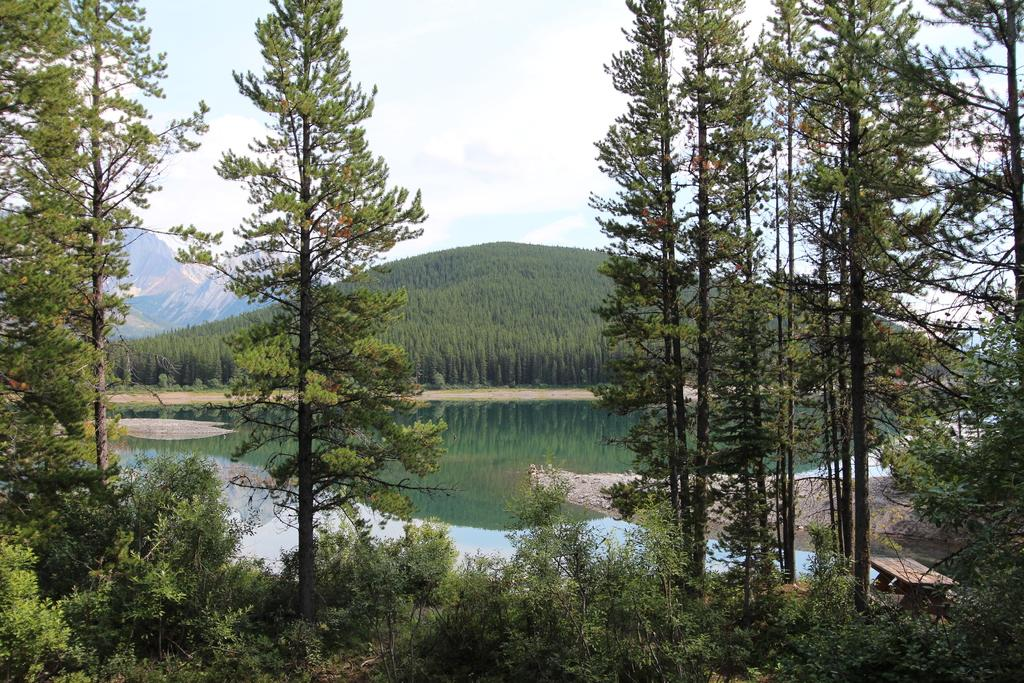What is located in the middle of the image? There are trees in the middle of the image. What is behind the trees in the image? There is water behind the trees. What is visible behind the water in the image? There are trees and hills behind the water. What is visible at the top of the image? Clouds and sky are visible at the top of the image. Where is the playground located in the image? There is no playground present in the image. What type of celery can be seen growing near the trees? There is no celery present in the image; it is a landscape featuring trees, water, and hills. 